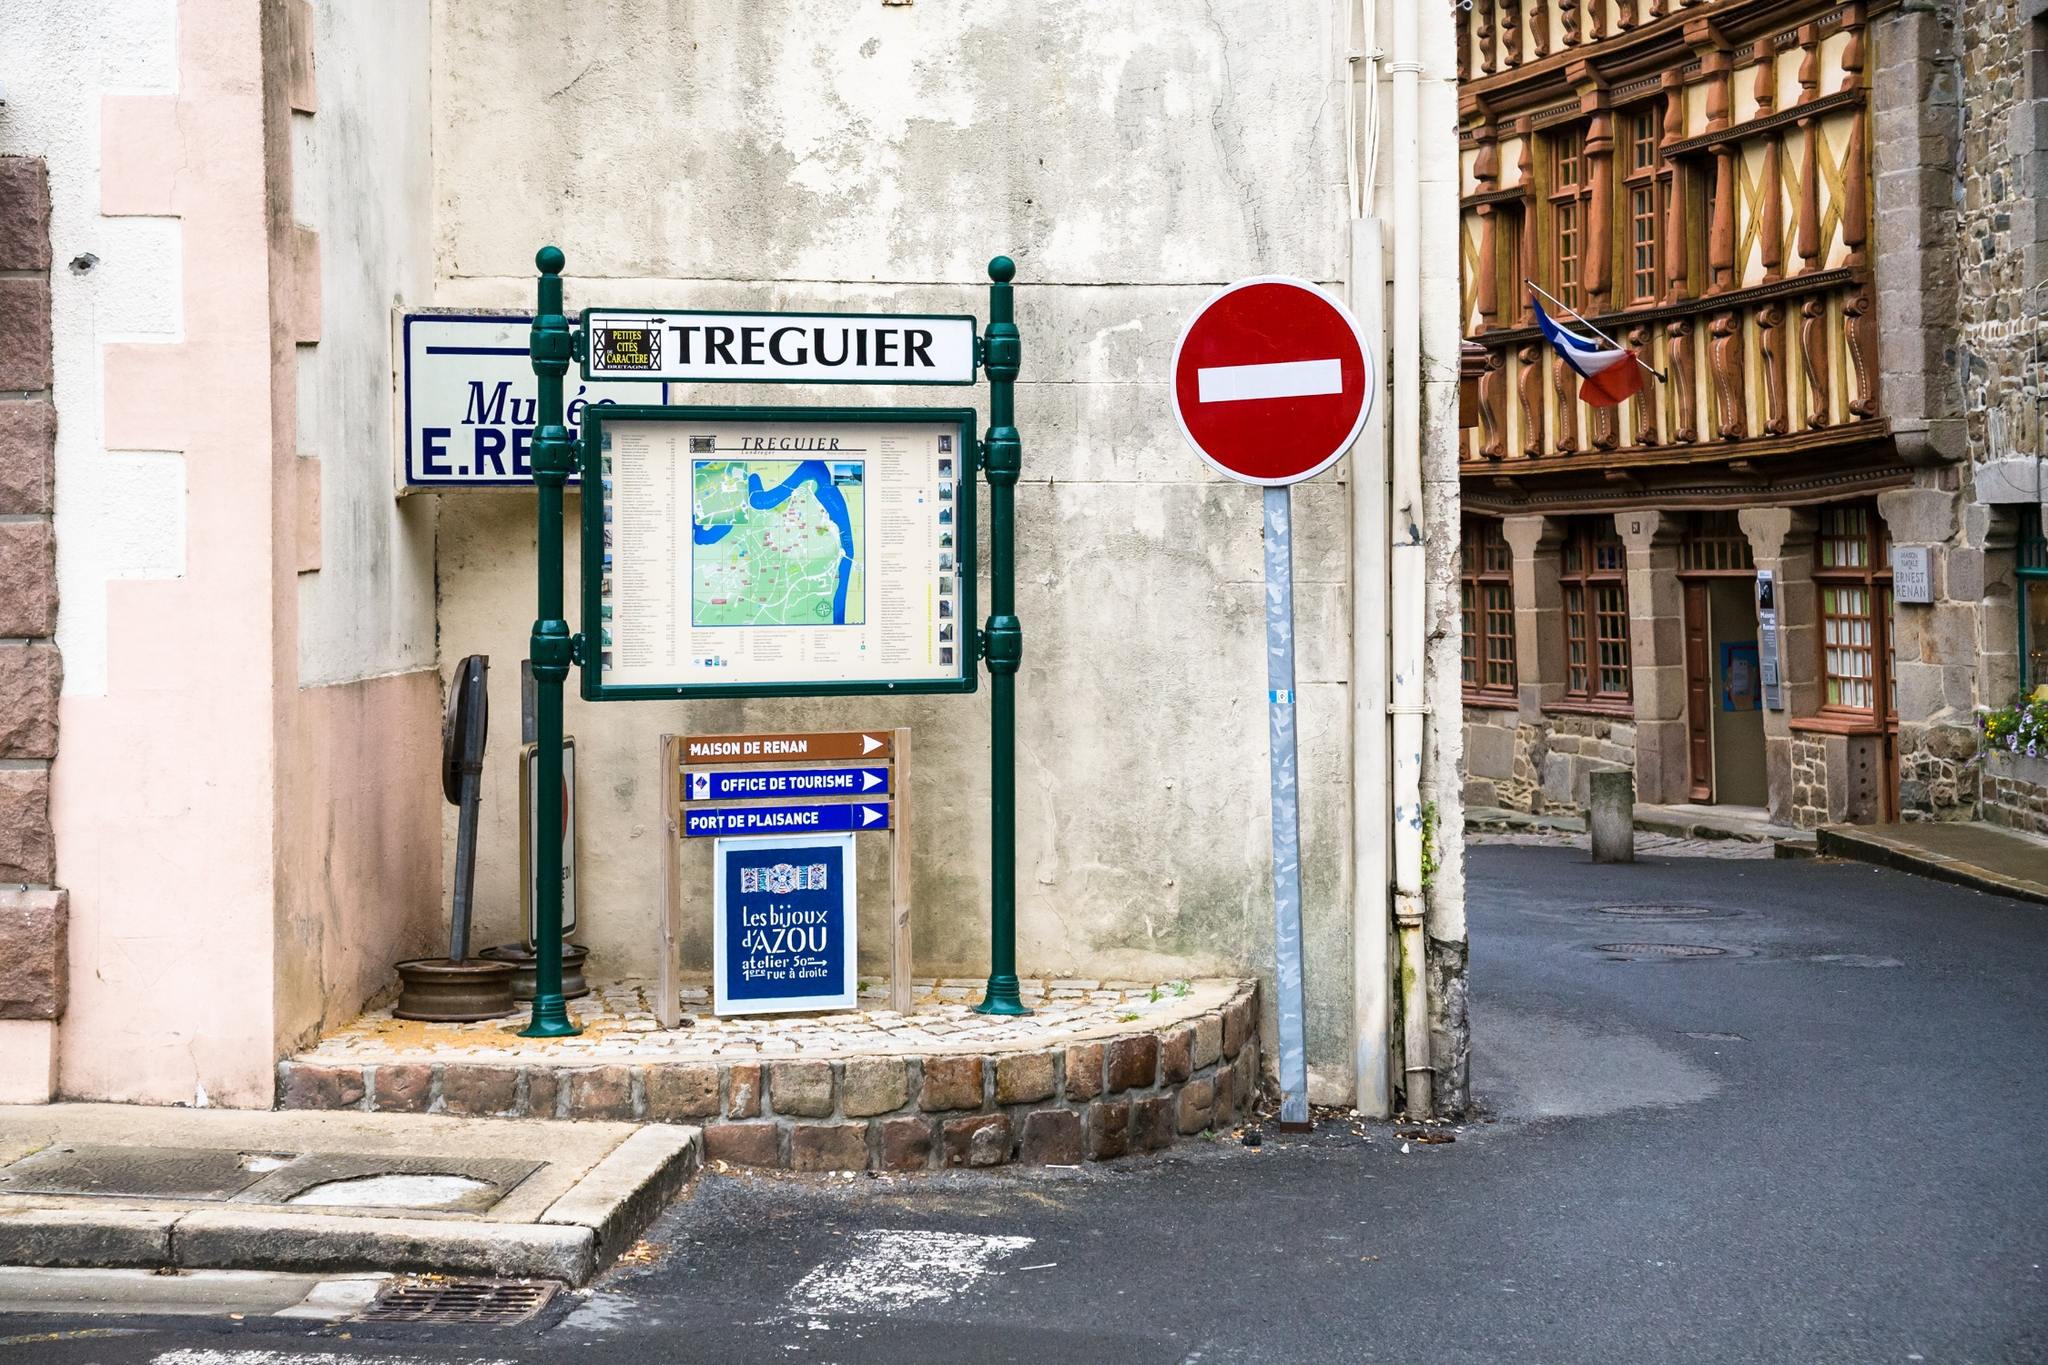Can you elaborate on the elements of the picture provided? The image captures a quaint street corner in the historic town of Tréguier, France. The cobblestone street, lined with buildings that whisper tales of the past, leads the eye towards a green and white signpost. This signpost, standing on a small brick island encircled by a white and green railing, holds a map of the town and a blue sign detailing the town's rich history. 

To the right of the signpost, a red and white no entry sign stands guard, ensuring the tranquility of the area. In the background, a building with a wooden facade proudly displays the French flag. A sign on the building reads "Musée E.R. Tréguier", indicating it as a place where the town's history is preserved and shared. A white car parked on the side of the road adds a touch of modern life to this picturesque scene.

The code "sa_1607" could be referring to the establishment of the Jamestown Colony in Virginia, USA in 1607[^1^][^2^]. However, it's unclear how this relates to the image of Tréguier, France. Perhaps there's a historical connection between these two places that isn't immediately apparent from the image. 